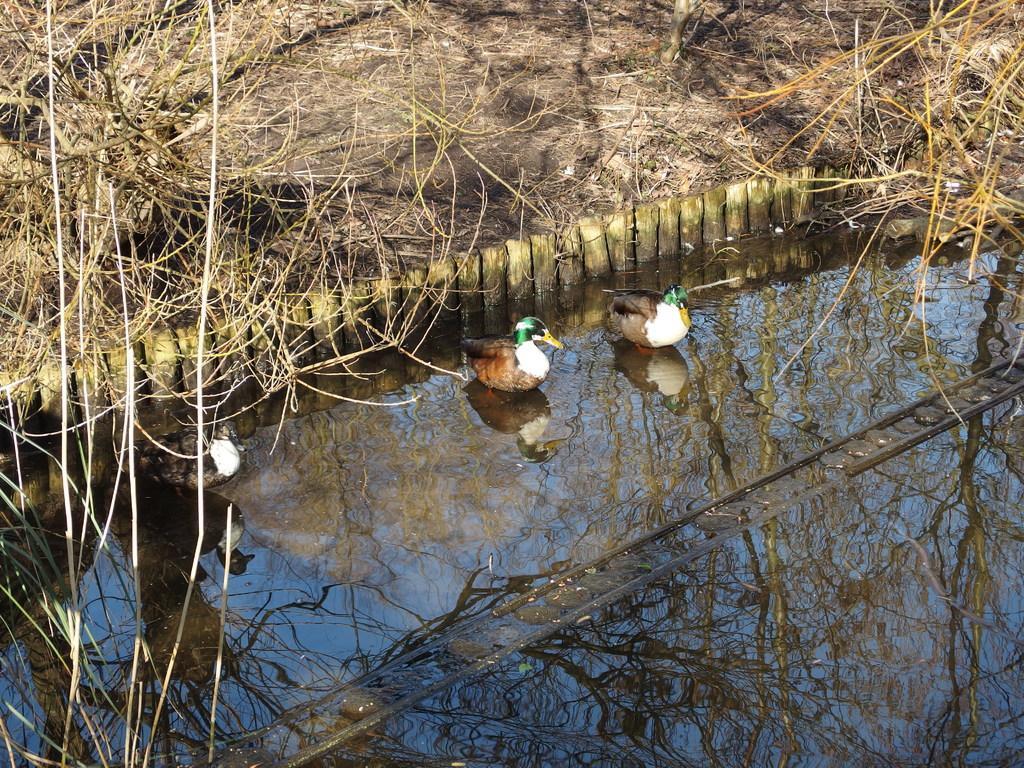How would you summarize this image in a sentence or two? In this image there is a lake on the bottom of this image and there are three ducks on to this lake as we can see in middle of this image and there are some grass on the top of this image. 